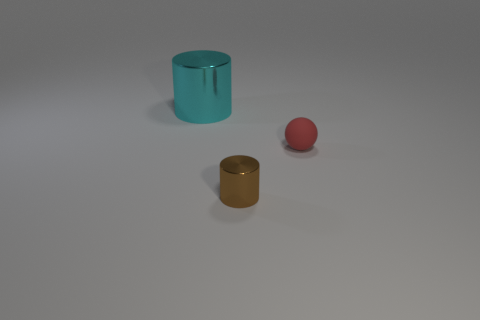Add 3 cyan cylinders. How many objects exist? 6 Subtract all balls. How many objects are left? 2 Subtract 0 gray cubes. How many objects are left? 3 Subtract all cyan cylinders. Subtract all small purple cubes. How many objects are left? 2 Add 2 red balls. How many red balls are left? 3 Add 1 big cylinders. How many big cylinders exist? 2 